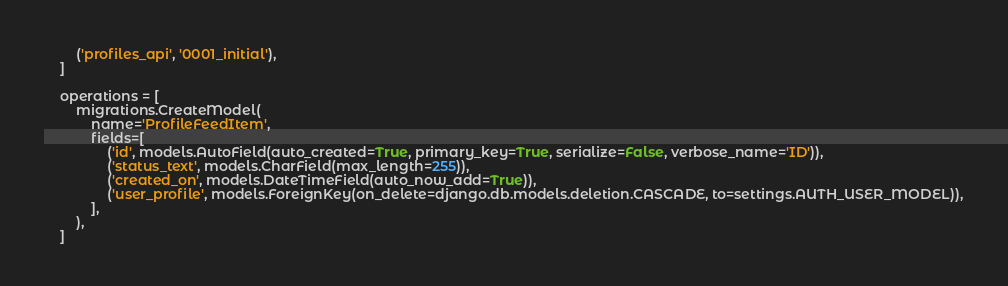Convert code to text. <code><loc_0><loc_0><loc_500><loc_500><_Python_>        ('profiles_api', '0001_initial'),
    ]

    operations = [
        migrations.CreateModel(
            name='ProfileFeedItem',
            fields=[
                ('id', models.AutoField(auto_created=True, primary_key=True, serialize=False, verbose_name='ID')),
                ('status_text', models.CharField(max_length=255)),
                ('created_on', models.DateTimeField(auto_now_add=True)),
                ('user_profile', models.ForeignKey(on_delete=django.db.models.deletion.CASCADE, to=settings.AUTH_USER_MODEL)),
            ],
        ),
    ]
</code> 